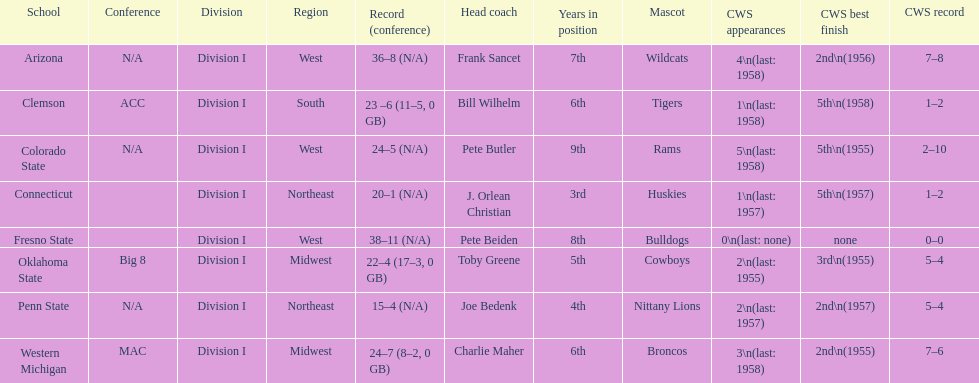Between clemson and western michigan, who has more appearances in the cws? Western Michigan. 